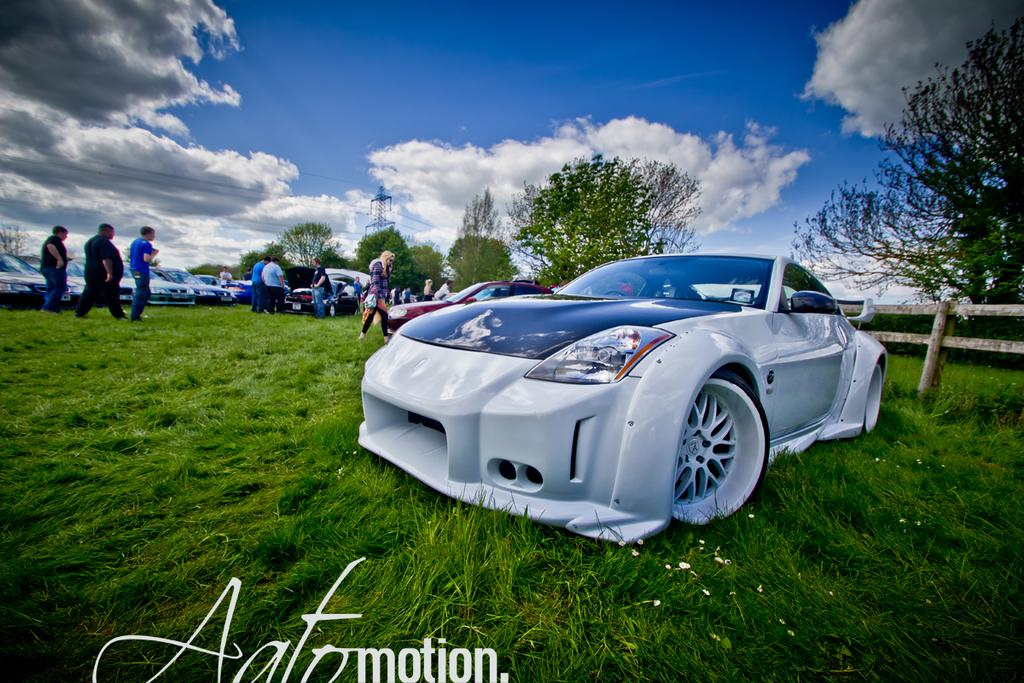What type of vehicles can be seen in the image? There are cars in the image. Are there any people present in the image? Yes, there are people in the image. What is the ground surface like in the image? The ground in the image has grass. What other natural elements can be seen in the image? There are trees in the image. How would you describe the sky in the image? The sky is visible in the image and appears to be cloudy. What type of furniture can be seen in the image? There is no furniture present in the image. How many birds are visible in the image? There are no birds visible in the image. 